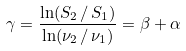Convert formula to latex. <formula><loc_0><loc_0><loc_500><loc_500>\gamma = \frac { \ln ( S _ { 2 } \, / \, S _ { 1 } ) } { \ln ( \nu _ { 2 } \, / \, \nu _ { 1 } ) } = \beta + \alpha</formula> 